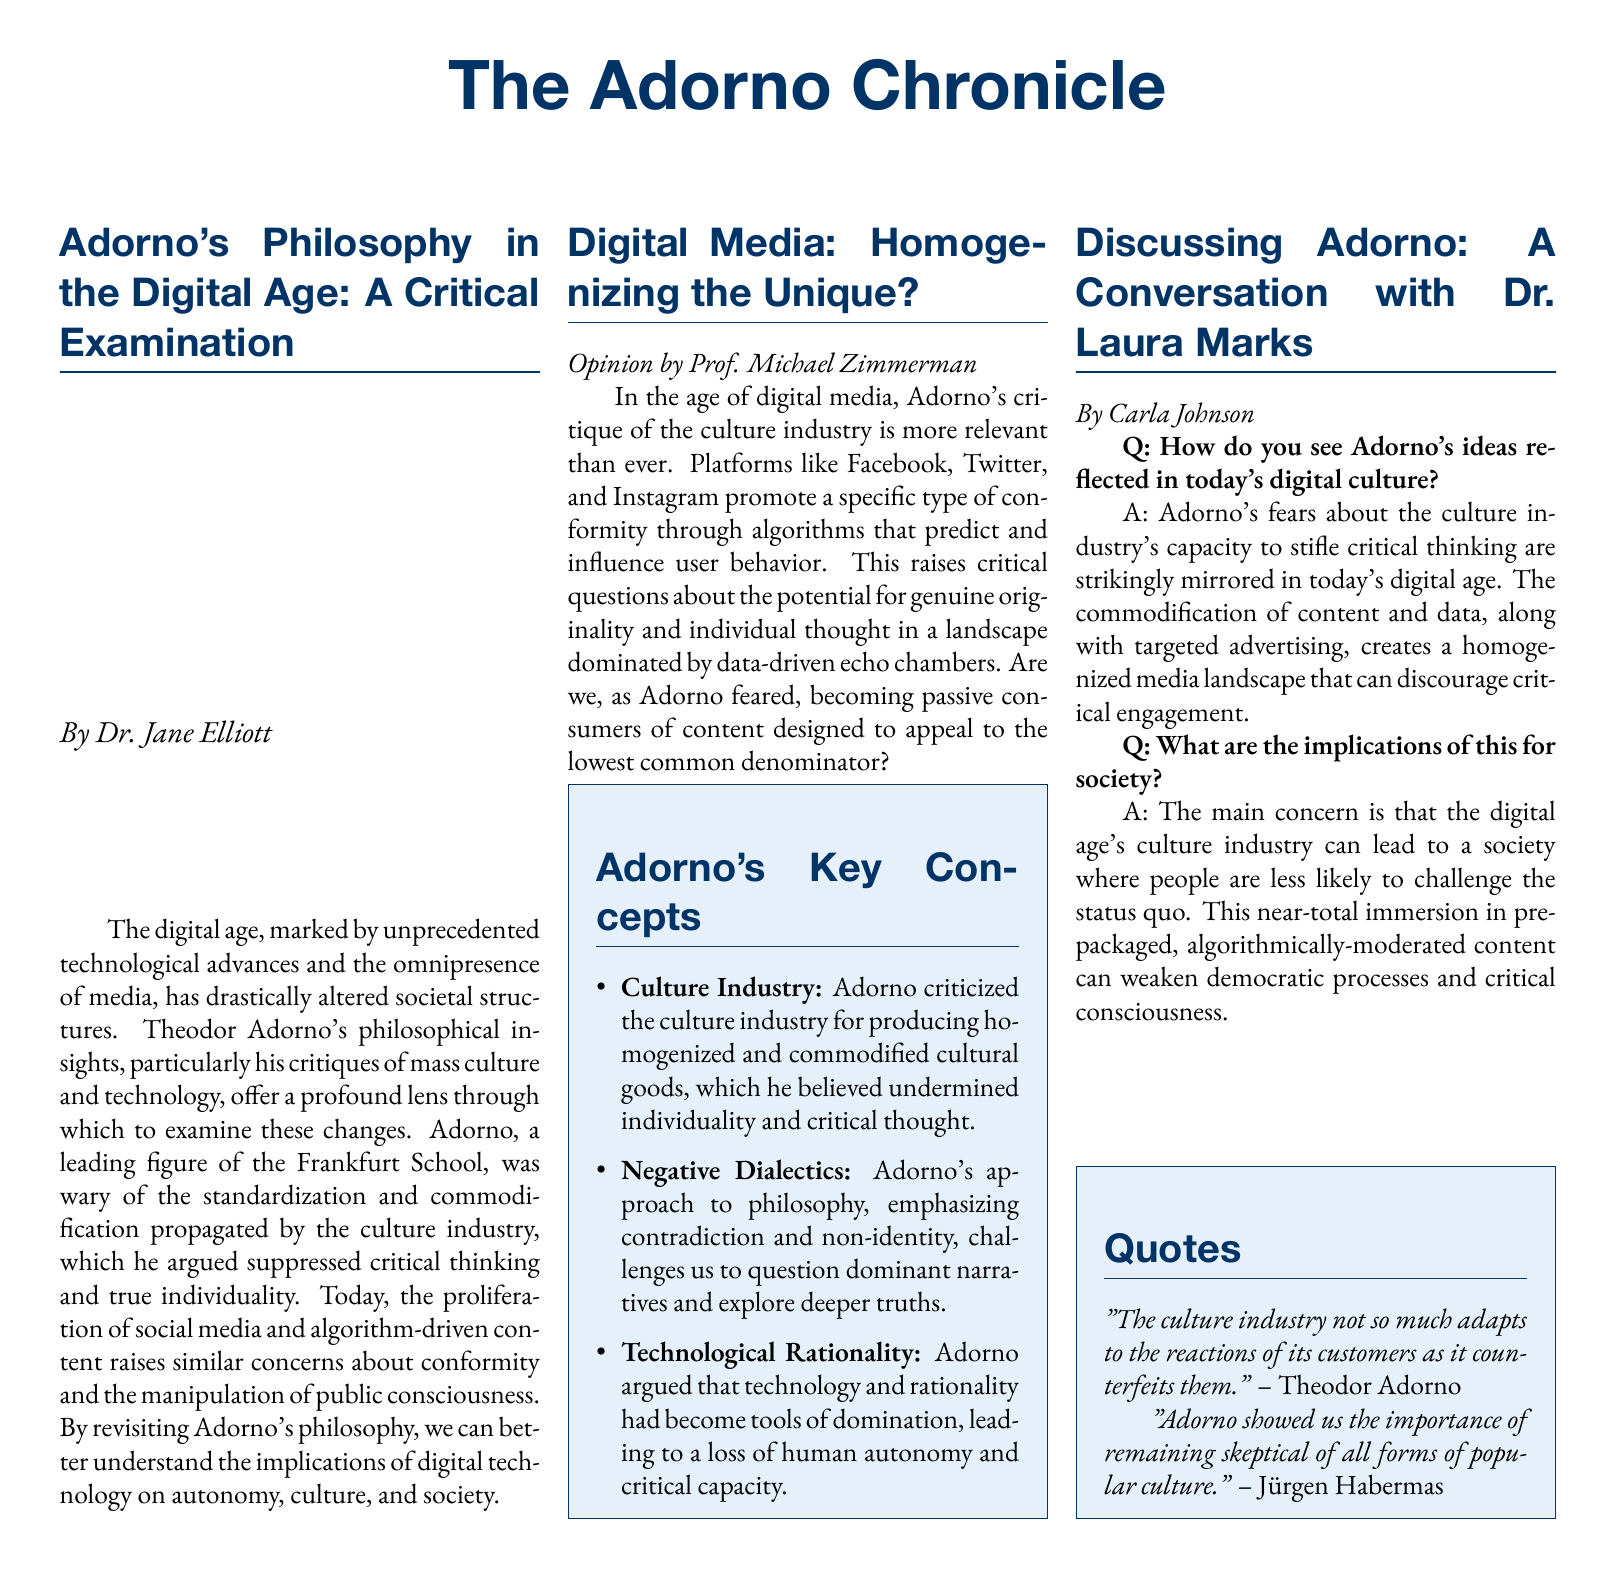What is the title of the document? The document is titled "The Adorno Chronicle," which is indicated at the top of the layout.
Answer: The Adorno Chronicle Who authored the first section on Adorno's philosophy? The first section is written by Dr. Jane Elliott, as stated in the byline.
Answer: Dr. Jane Elliott What are Adorno's key concepts listed in the document? The document lists three key concepts: Culture Industry, Negative Dialectics, and Technological Rationality.
Answer: Culture Industry, Negative Dialectics, Technological Rationality What does Dr. Laura Marks say about Adorno's fears? Dr. Marks explains that Adorno's fears are mirrored in today's digital age, specifically regarding critical thinking.
Answer: Stifle critical thinking How does the opinion piece describe the impact of social media platforms? The opinion piece discusses conformity through algorithms and the risk of passive consumption of content shaped by these platforms.
Answer: Conformity through algorithms Which philosopher cites the importance of skepticism in popular culture? The document includes a quote from Jürgen Habermas regarding the importance of skepticism in popular culture.
Answer: Jürgen Habermas How many multicolumn sections exist in the document? The document is structured into three separate multicolumn sections discussing various aspects of Adorno's philosophy.
Answer: Three What color is used for section headings in the document? The section headings are styled in a blue color defined as adornoblue within the document.
Answer: Adornoblue 